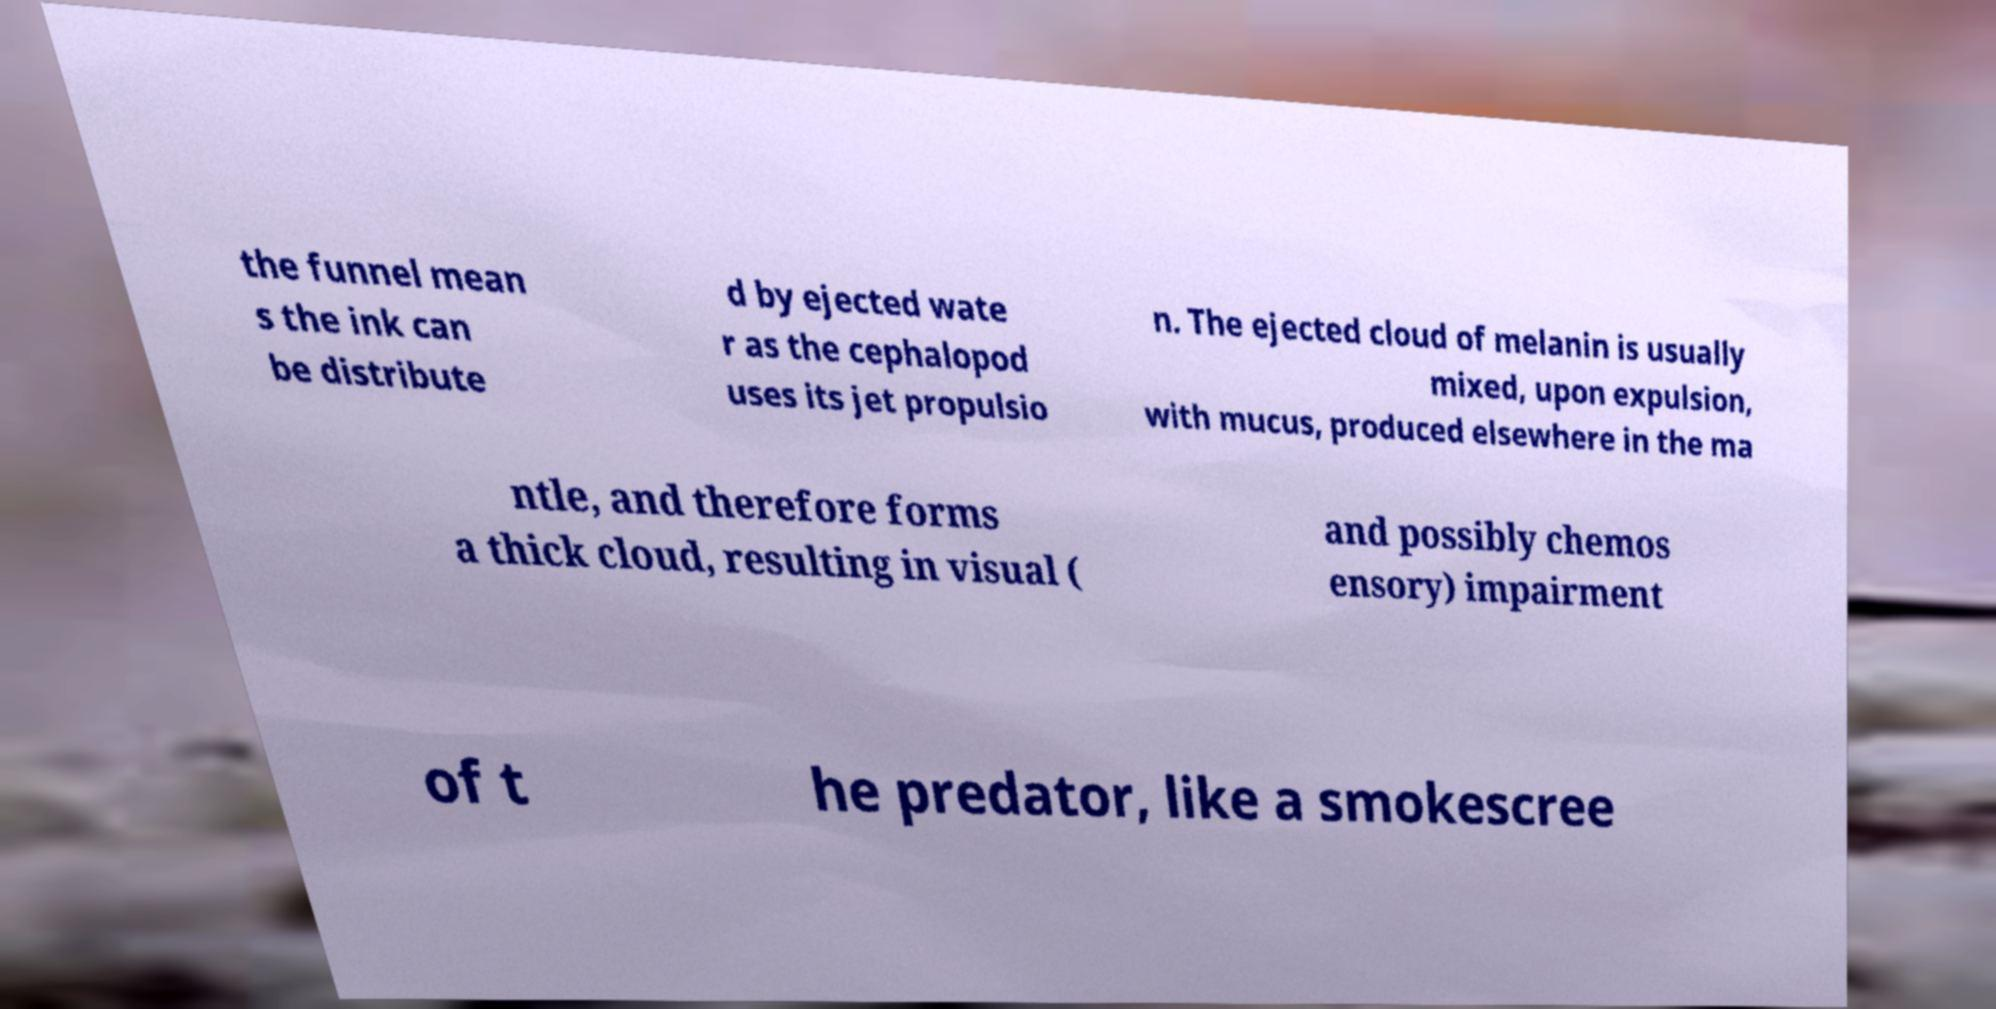Please read and relay the text visible in this image. What does it say? the funnel mean s the ink can be distribute d by ejected wate r as the cephalopod uses its jet propulsio n. The ejected cloud of melanin is usually mixed, upon expulsion, with mucus, produced elsewhere in the ma ntle, and therefore forms a thick cloud, resulting in visual ( and possibly chemos ensory) impairment of t he predator, like a smokescree 